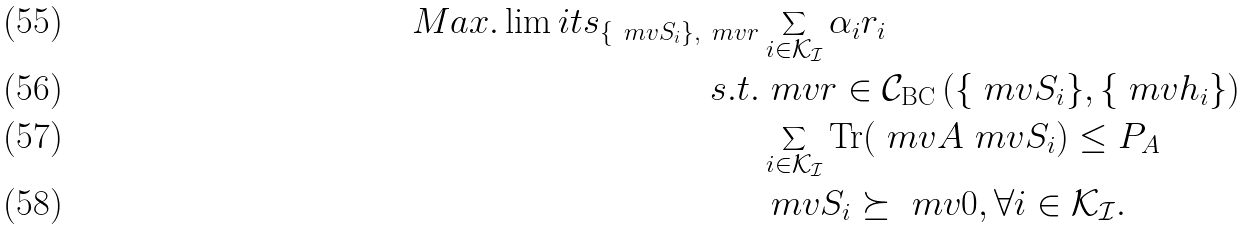<formula> <loc_0><loc_0><loc_500><loc_500>M a x . \lim i t s _ { \left \{ \ m v { S } _ { i } \right \} , \ m v { r } } & \sum _ { i \in \mathcal { K _ { I } } } \alpha _ { i } r _ { i } \\ s . t . & \ m v { r } \in \mathcal { C } _ { \text {BC} } \left ( \{ \ m v { S } _ { i } \} , \{ \ m v { h } _ { i } \} \right ) \\ & \sum _ { i \in \mathcal { K _ { I } } } \text {Tr} ( \ m v { A } \ m v { S } _ { i } ) \leq P _ { A } \\ & \ m v { S } _ { i } \succeq \ m v { 0 } , \forall i \in \mathcal { K _ { I } } .</formula> 